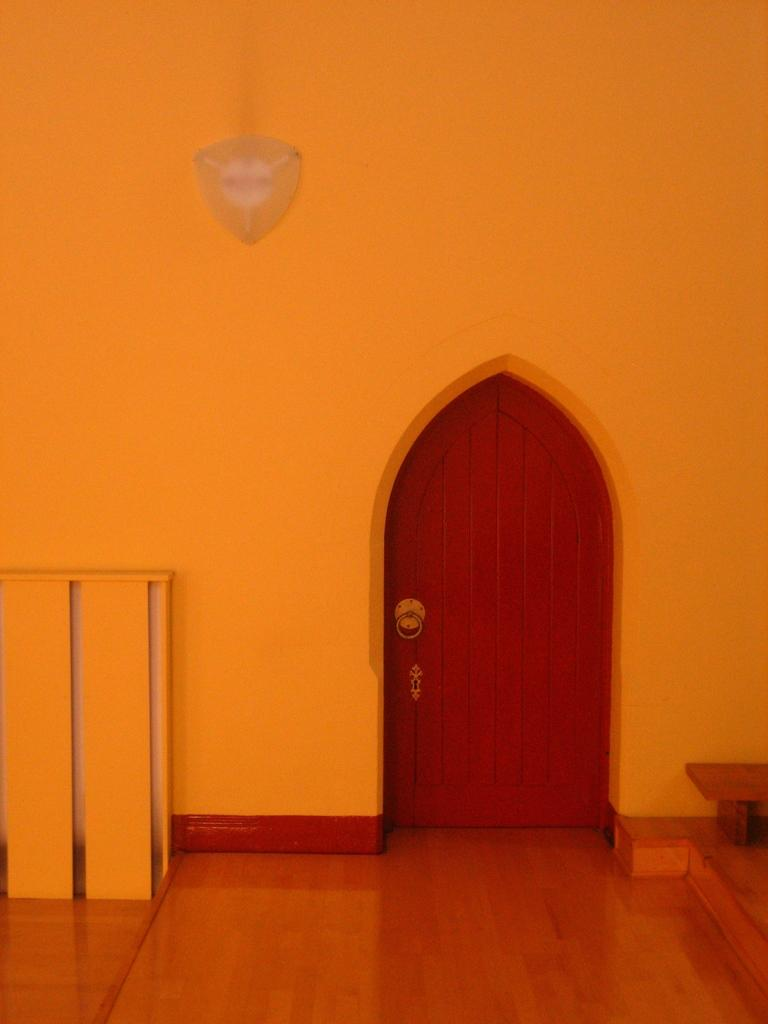What type of structure can be seen in the image? There is a door in the image. What type of furniture is present in the image? There is a bench in the image. What type of architectural element is visible in the image? There is a wall in the image. What object is present in the image? There is an object in the image. What can be found in the foreground of the image? The foreground of the image consists of a well. How does the brain attempt to solve the test in the image? There is no brain, test, or attempt present in the image; it only features a door, bench, wall, object, and a well in the foreground. 